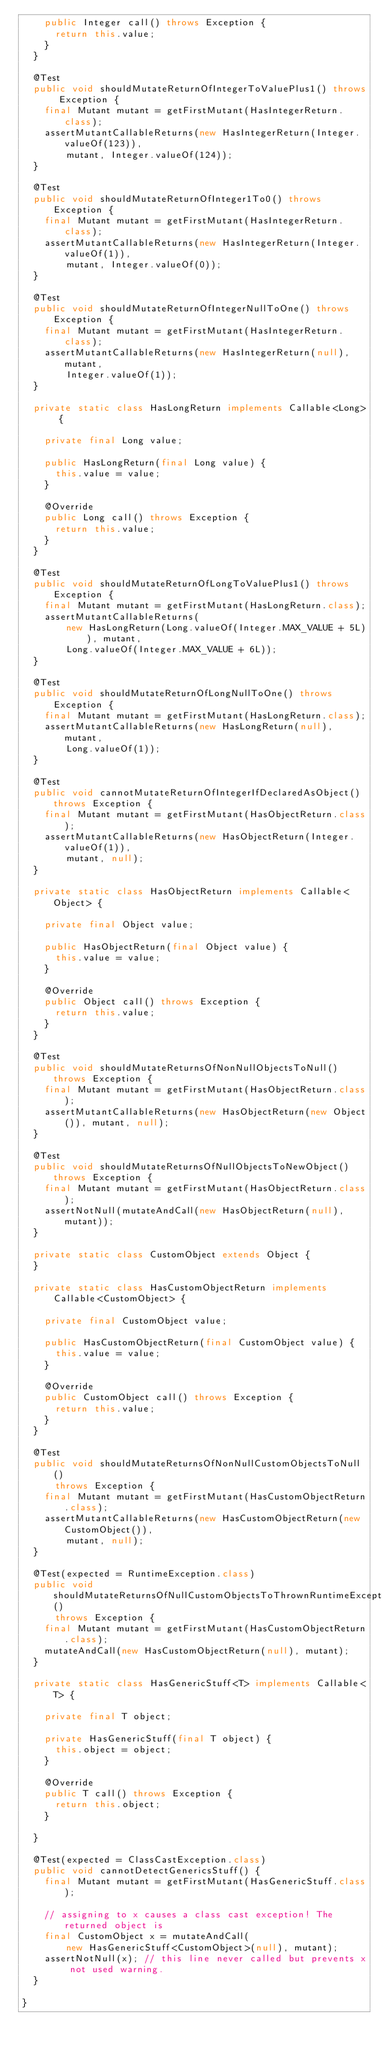<code> <loc_0><loc_0><loc_500><loc_500><_Java_>    public Integer call() throws Exception {
      return this.value;
    }
  }

  @Test
  public void shouldMutateReturnOfIntegerToValuePlus1() throws Exception {
    final Mutant mutant = getFirstMutant(HasIntegerReturn.class);
    assertMutantCallableReturns(new HasIntegerReturn(Integer.valueOf(123)),
        mutant, Integer.valueOf(124));
  }

  @Test
  public void shouldMutateReturnOfInteger1To0() throws Exception {
    final Mutant mutant = getFirstMutant(HasIntegerReturn.class);
    assertMutantCallableReturns(new HasIntegerReturn(Integer.valueOf(1)),
        mutant, Integer.valueOf(0));
  }

  @Test
  public void shouldMutateReturnOfIntegerNullToOne() throws Exception {
    final Mutant mutant = getFirstMutant(HasIntegerReturn.class);
    assertMutantCallableReturns(new HasIntegerReturn(null), mutant,
        Integer.valueOf(1));
  }

  private static class HasLongReturn implements Callable<Long> {

    private final Long value;

    public HasLongReturn(final Long value) {
      this.value = value;
    }

    @Override
    public Long call() throws Exception {
      return this.value;
    }
  }

  @Test
  public void shouldMutateReturnOfLongToValuePlus1() throws Exception {
    final Mutant mutant = getFirstMutant(HasLongReturn.class);
    assertMutantCallableReturns(
        new HasLongReturn(Long.valueOf(Integer.MAX_VALUE + 5L)), mutant,
        Long.valueOf(Integer.MAX_VALUE + 6L));
  }

  @Test
  public void shouldMutateReturnOfLongNullToOne() throws Exception {
    final Mutant mutant = getFirstMutant(HasLongReturn.class);
    assertMutantCallableReturns(new HasLongReturn(null), mutant,
        Long.valueOf(1));
  }

  @Test
  public void cannotMutateReturnOfIntegerIfDeclaredAsObject() throws Exception {
    final Mutant mutant = getFirstMutant(HasObjectReturn.class);
    assertMutantCallableReturns(new HasObjectReturn(Integer.valueOf(1)),
        mutant, null);
  }

  private static class HasObjectReturn implements Callable<Object> {

    private final Object value;

    public HasObjectReturn(final Object value) {
      this.value = value;
    }

    @Override
    public Object call() throws Exception {
      return this.value;
    }
  }

  @Test
  public void shouldMutateReturnsOfNonNullObjectsToNull() throws Exception {
    final Mutant mutant = getFirstMutant(HasObjectReturn.class);
    assertMutantCallableReturns(new HasObjectReturn(new Object()), mutant, null);
  }

  @Test
  public void shouldMutateReturnsOfNullObjectsToNewObject() throws Exception {
    final Mutant mutant = getFirstMutant(HasObjectReturn.class);
    assertNotNull(mutateAndCall(new HasObjectReturn(null), mutant));
  }

  private static class CustomObject extends Object {
  }

  private static class HasCustomObjectReturn implements Callable<CustomObject> {

    private final CustomObject value;

    public HasCustomObjectReturn(final CustomObject value) {
      this.value = value;
    }

    @Override
    public CustomObject call() throws Exception {
      return this.value;
    }
  }

  @Test
  public void shouldMutateReturnsOfNonNullCustomObjectsToNull()
      throws Exception {
    final Mutant mutant = getFirstMutant(HasCustomObjectReturn.class);
    assertMutantCallableReturns(new HasCustomObjectReturn(new CustomObject()),
        mutant, null);
  }

  @Test(expected = RuntimeException.class)
  public void shouldMutateReturnsOfNullCustomObjectsToThrownRuntimeException()
      throws Exception {
    final Mutant mutant = getFirstMutant(HasCustomObjectReturn.class);
    mutateAndCall(new HasCustomObjectReturn(null), mutant);
  }

  private static class HasGenericStuff<T> implements Callable<T> {

    private final T object;

    private HasGenericStuff(final T object) {
      this.object = object;
    }

    @Override
    public T call() throws Exception {
      return this.object;
    }

  }

  @Test(expected = ClassCastException.class)
  public void cannotDetectGenericsStuff() {
    final Mutant mutant = getFirstMutant(HasGenericStuff.class);

    // assigning to x causes a class cast exception! The returned object is
    final CustomObject x = mutateAndCall(
        new HasGenericStuff<CustomObject>(null), mutant);
    assertNotNull(x); // this line never called but prevents x not used warning.
  }

}
</code> 